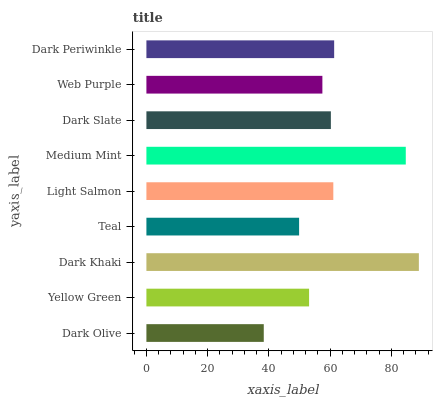Is Dark Olive the minimum?
Answer yes or no. Yes. Is Dark Khaki the maximum?
Answer yes or no. Yes. Is Yellow Green the minimum?
Answer yes or no. No. Is Yellow Green the maximum?
Answer yes or no. No. Is Yellow Green greater than Dark Olive?
Answer yes or no. Yes. Is Dark Olive less than Yellow Green?
Answer yes or no. Yes. Is Dark Olive greater than Yellow Green?
Answer yes or no. No. Is Yellow Green less than Dark Olive?
Answer yes or no. No. Is Dark Slate the high median?
Answer yes or no. Yes. Is Dark Slate the low median?
Answer yes or no. Yes. Is Web Purple the high median?
Answer yes or no. No. Is Teal the low median?
Answer yes or no. No. 